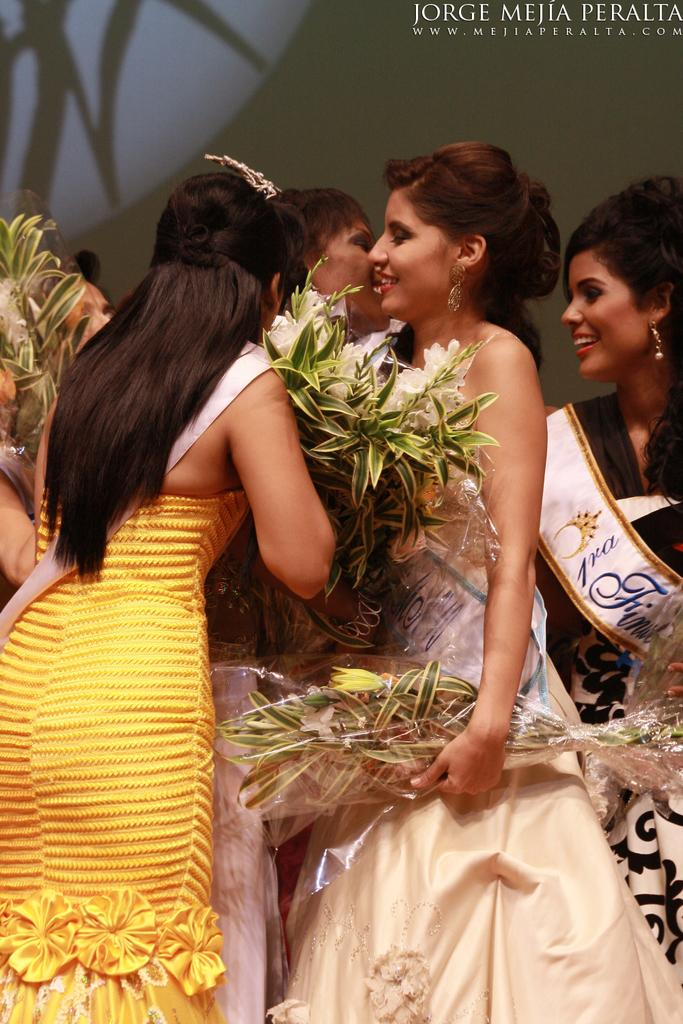What is the main subject of the image? The main subject of the image is the girls in the center of the image. What are the girls holding in their hands? The girls are holding flowers in their hands. What can be seen in the background of the image? There is a poster in the background of the image. What type of thing is the girls' sister doing in the image? There is no mention of a sister in the image, so it cannot be determined what a sister might be doing. 